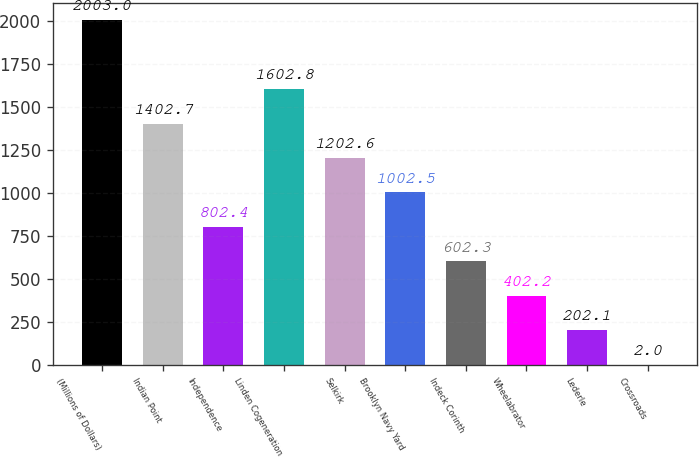<chart> <loc_0><loc_0><loc_500><loc_500><bar_chart><fcel>(Millions of Dollars)<fcel>Indian Point<fcel>Independence<fcel>Linden Cogeneration<fcel>Selkirk<fcel>Brooklyn Navy Yard<fcel>Indeck Corinth<fcel>Wheelabrator<fcel>Lederle<fcel>Crossroads<nl><fcel>2003<fcel>1402.7<fcel>802.4<fcel>1602.8<fcel>1202.6<fcel>1002.5<fcel>602.3<fcel>402.2<fcel>202.1<fcel>2<nl></chart> 